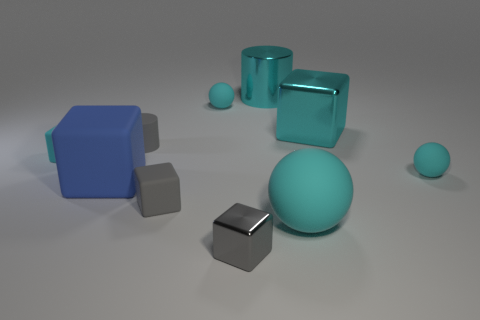Subtract all small matte blocks. How many blocks are left? 3 Subtract 1 cubes. How many cubes are left? 4 Subtract all cyan cubes. How many cubes are left? 3 Subtract all green blocks. Subtract all cyan spheres. How many blocks are left? 5 Subtract 2 gray cubes. How many objects are left? 8 Subtract all spheres. How many objects are left? 7 Subtract all small matte cylinders. Subtract all gray matte objects. How many objects are left? 7 Add 2 cyan balls. How many cyan balls are left? 5 Add 2 big cyan cubes. How many big cyan cubes exist? 3 